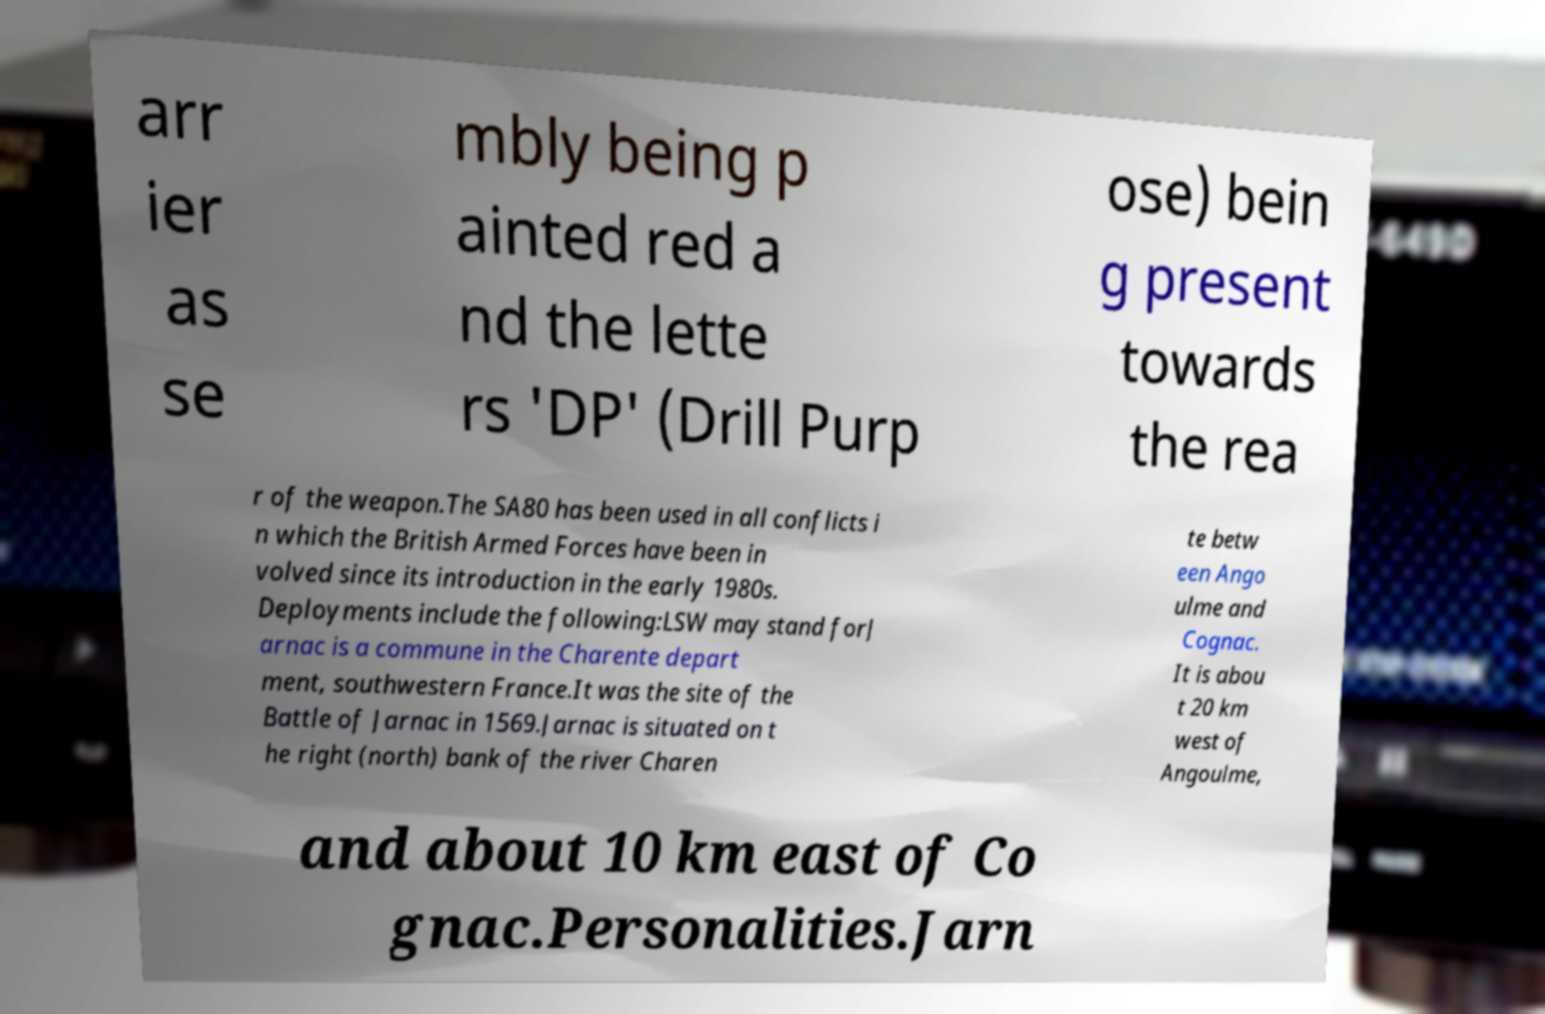Could you extract and type out the text from this image? arr ier as se mbly being p ainted red a nd the lette rs 'DP' (Drill Purp ose) bein g present towards the rea r of the weapon.The SA80 has been used in all conflicts i n which the British Armed Forces have been in volved since its introduction in the early 1980s. Deployments include the following:LSW may stand forJ arnac is a commune in the Charente depart ment, southwestern France.It was the site of the Battle of Jarnac in 1569.Jarnac is situated on t he right (north) bank of the river Charen te betw een Ango ulme and Cognac. It is abou t 20 km west of Angoulme, and about 10 km east of Co gnac.Personalities.Jarn 